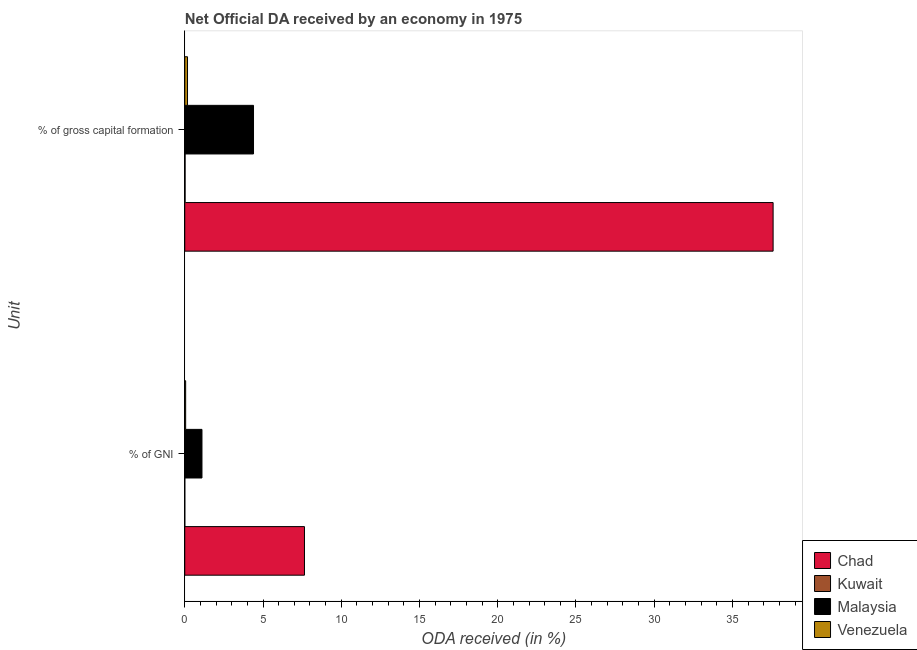How many different coloured bars are there?
Make the answer very short. 4. How many groups of bars are there?
Keep it short and to the point. 2. Are the number of bars on each tick of the Y-axis equal?
Make the answer very short. Yes. What is the label of the 1st group of bars from the top?
Ensure brevity in your answer.  % of gross capital formation. What is the oda received as percentage of gross capital formation in Kuwait?
Provide a short and direct response. 0.02. Across all countries, what is the maximum oda received as percentage of gni?
Provide a succinct answer. 7.65. Across all countries, what is the minimum oda received as percentage of gni?
Offer a terse response. 0. In which country was the oda received as percentage of gni maximum?
Your response must be concise. Chad. In which country was the oda received as percentage of gross capital formation minimum?
Provide a short and direct response. Kuwait. What is the total oda received as percentage of gni in the graph?
Give a very brief answer. 8.81. What is the difference between the oda received as percentage of gni in Venezuela and that in Chad?
Your response must be concise. -7.59. What is the difference between the oda received as percentage of gni in Chad and the oda received as percentage of gross capital formation in Kuwait?
Offer a very short reply. 7.63. What is the average oda received as percentage of gross capital formation per country?
Provide a short and direct response. 10.55. What is the difference between the oda received as percentage of gni and oda received as percentage of gross capital formation in Venezuela?
Your answer should be compact. -0.12. In how many countries, is the oda received as percentage of gni greater than 23 %?
Give a very brief answer. 0. What is the ratio of the oda received as percentage of gross capital formation in Chad to that in Kuwait?
Provide a succinct answer. 1742.96. Is the oda received as percentage of gni in Venezuela less than that in Kuwait?
Offer a very short reply. No. What does the 3rd bar from the top in % of GNI represents?
Offer a terse response. Kuwait. What does the 3rd bar from the bottom in % of gross capital formation represents?
Provide a short and direct response. Malaysia. How many bars are there?
Provide a short and direct response. 8. What is the difference between two consecutive major ticks on the X-axis?
Your response must be concise. 5. Are the values on the major ticks of X-axis written in scientific E-notation?
Offer a terse response. No. Does the graph contain grids?
Make the answer very short. No. Where does the legend appear in the graph?
Ensure brevity in your answer.  Bottom right. What is the title of the graph?
Offer a terse response. Net Official DA received by an economy in 1975. Does "Kuwait" appear as one of the legend labels in the graph?
Make the answer very short. Yes. What is the label or title of the X-axis?
Provide a short and direct response. ODA received (in %). What is the label or title of the Y-axis?
Provide a succinct answer. Unit. What is the ODA received (in %) of Chad in % of GNI?
Your answer should be compact. 7.65. What is the ODA received (in %) in Kuwait in % of GNI?
Provide a short and direct response. 0. What is the ODA received (in %) in Malaysia in % of GNI?
Your answer should be very brief. 1.1. What is the ODA received (in %) of Venezuela in % of GNI?
Provide a short and direct response. 0.06. What is the ODA received (in %) in Chad in % of gross capital formation?
Give a very brief answer. 37.6. What is the ODA received (in %) in Kuwait in % of gross capital formation?
Your answer should be compact. 0.02. What is the ODA received (in %) of Malaysia in % of gross capital formation?
Make the answer very short. 4.39. What is the ODA received (in %) of Venezuela in % of gross capital formation?
Provide a succinct answer. 0.18. Across all Unit, what is the maximum ODA received (in %) in Chad?
Your answer should be very brief. 37.6. Across all Unit, what is the maximum ODA received (in %) of Kuwait?
Offer a terse response. 0.02. Across all Unit, what is the maximum ODA received (in %) in Malaysia?
Keep it short and to the point. 4.39. Across all Unit, what is the maximum ODA received (in %) in Venezuela?
Your answer should be very brief. 0.18. Across all Unit, what is the minimum ODA received (in %) in Chad?
Your answer should be very brief. 7.65. Across all Unit, what is the minimum ODA received (in %) of Kuwait?
Keep it short and to the point. 0. Across all Unit, what is the minimum ODA received (in %) of Malaysia?
Offer a terse response. 1.1. Across all Unit, what is the minimum ODA received (in %) in Venezuela?
Keep it short and to the point. 0.06. What is the total ODA received (in %) of Chad in the graph?
Your answer should be compact. 45.25. What is the total ODA received (in %) of Kuwait in the graph?
Offer a terse response. 0.02. What is the total ODA received (in %) in Malaysia in the graph?
Your answer should be very brief. 5.49. What is the total ODA received (in %) in Venezuela in the graph?
Keep it short and to the point. 0.23. What is the difference between the ODA received (in %) in Chad in % of GNI and that in % of gross capital formation?
Your answer should be compact. -29.95. What is the difference between the ODA received (in %) in Kuwait in % of GNI and that in % of gross capital formation?
Make the answer very short. -0.02. What is the difference between the ODA received (in %) in Malaysia in % of GNI and that in % of gross capital formation?
Give a very brief answer. -3.29. What is the difference between the ODA received (in %) of Venezuela in % of GNI and that in % of gross capital formation?
Your response must be concise. -0.12. What is the difference between the ODA received (in %) of Chad in % of GNI and the ODA received (in %) of Kuwait in % of gross capital formation?
Make the answer very short. 7.63. What is the difference between the ODA received (in %) of Chad in % of GNI and the ODA received (in %) of Malaysia in % of gross capital formation?
Your answer should be very brief. 3.26. What is the difference between the ODA received (in %) of Chad in % of GNI and the ODA received (in %) of Venezuela in % of gross capital formation?
Offer a terse response. 7.47. What is the difference between the ODA received (in %) of Kuwait in % of GNI and the ODA received (in %) of Malaysia in % of gross capital formation?
Make the answer very short. -4.39. What is the difference between the ODA received (in %) of Kuwait in % of GNI and the ODA received (in %) of Venezuela in % of gross capital formation?
Your response must be concise. -0.17. What is the difference between the ODA received (in %) of Malaysia in % of GNI and the ODA received (in %) of Venezuela in % of gross capital formation?
Offer a terse response. 0.92. What is the average ODA received (in %) of Chad per Unit?
Offer a very short reply. 22.62. What is the average ODA received (in %) in Kuwait per Unit?
Your answer should be compact. 0.01. What is the average ODA received (in %) in Malaysia per Unit?
Keep it short and to the point. 2.75. What is the average ODA received (in %) of Venezuela per Unit?
Make the answer very short. 0.12. What is the difference between the ODA received (in %) of Chad and ODA received (in %) of Kuwait in % of GNI?
Your answer should be compact. 7.65. What is the difference between the ODA received (in %) in Chad and ODA received (in %) in Malaysia in % of GNI?
Provide a short and direct response. 6.55. What is the difference between the ODA received (in %) in Chad and ODA received (in %) in Venezuela in % of GNI?
Provide a succinct answer. 7.59. What is the difference between the ODA received (in %) in Kuwait and ODA received (in %) in Malaysia in % of GNI?
Give a very brief answer. -1.1. What is the difference between the ODA received (in %) in Kuwait and ODA received (in %) in Venezuela in % of GNI?
Give a very brief answer. -0.06. What is the difference between the ODA received (in %) of Malaysia and ODA received (in %) of Venezuela in % of GNI?
Your answer should be compact. 1.04. What is the difference between the ODA received (in %) of Chad and ODA received (in %) of Kuwait in % of gross capital formation?
Your response must be concise. 37.58. What is the difference between the ODA received (in %) in Chad and ODA received (in %) in Malaysia in % of gross capital formation?
Offer a very short reply. 33.2. What is the difference between the ODA received (in %) in Chad and ODA received (in %) in Venezuela in % of gross capital formation?
Your answer should be compact. 37.42. What is the difference between the ODA received (in %) in Kuwait and ODA received (in %) in Malaysia in % of gross capital formation?
Offer a very short reply. -4.37. What is the difference between the ODA received (in %) in Kuwait and ODA received (in %) in Venezuela in % of gross capital formation?
Your answer should be very brief. -0.15. What is the difference between the ODA received (in %) of Malaysia and ODA received (in %) of Venezuela in % of gross capital formation?
Your answer should be very brief. 4.22. What is the ratio of the ODA received (in %) in Chad in % of GNI to that in % of gross capital formation?
Your answer should be very brief. 0.2. What is the ratio of the ODA received (in %) in Kuwait in % of GNI to that in % of gross capital formation?
Provide a succinct answer. 0.12. What is the ratio of the ODA received (in %) of Malaysia in % of GNI to that in % of gross capital formation?
Give a very brief answer. 0.25. What is the ratio of the ODA received (in %) in Venezuela in % of GNI to that in % of gross capital formation?
Ensure brevity in your answer.  0.33. What is the difference between the highest and the second highest ODA received (in %) in Chad?
Keep it short and to the point. 29.95. What is the difference between the highest and the second highest ODA received (in %) of Kuwait?
Offer a terse response. 0.02. What is the difference between the highest and the second highest ODA received (in %) in Malaysia?
Offer a terse response. 3.29. What is the difference between the highest and the second highest ODA received (in %) of Venezuela?
Ensure brevity in your answer.  0.12. What is the difference between the highest and the lowest ODA received (in %) in Chad?
Offer a terse response. 29.95. What is the difference between the highest and the lowest ODA received (in %) of Kuwait?
Offer a very short reply. 0.02. What is the difference between the highest and the lowest ODA received (in %) of Malaysia?
Offer a terse response. 3.29. What is the difference between the highest and the lowest ODA received (in %) in Venezuela?
Your answer should be very brief. 0.12. 